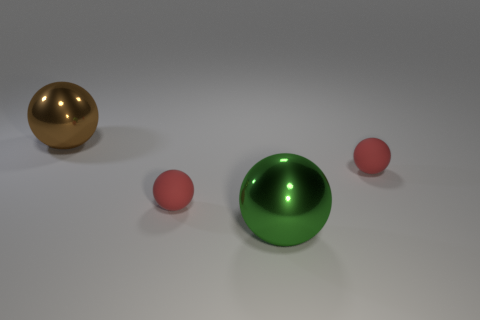There is a object that is both on the left side of the green shiny thing and to the right of the big brown thing; what shape is it?
Ensure brevity in your answer.  Sphere. Are there fewer brown objects behind the large brown shiny object than small spheres?
Give a very brief answer. Yes. How many tiny objects are either gray matte balls or metal objects?
Make the answer very short. 0. What is the size of the brown object?
Keep it short and to the point. Large. Are there any other things that are made of the same material as the green object?
Give a very brief answer. Yes. There is a brown metal ball; how many large brown shiny things are in front of it?
Make the answer very short. 0. There is a green metal object that is the same shape as the brown shiny object; what size is it?
Give a very brief answer. Large. What size is the sphere that is on the left side of the big green metal sphere and right of the large brown metal ball?
Ensure brevity in your answer.  Small. How many brown objects are large cubes or matte things?
Offer a very short reply. 0. How many other things are the same shape as the large brown object?
Your answer should be compact. 3. 